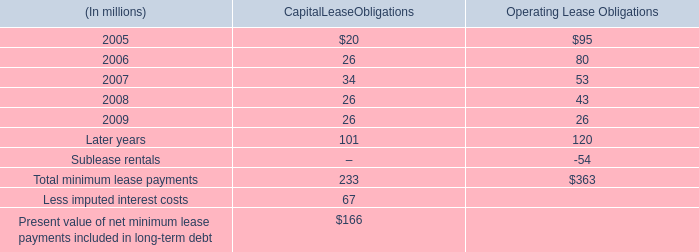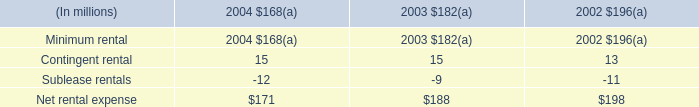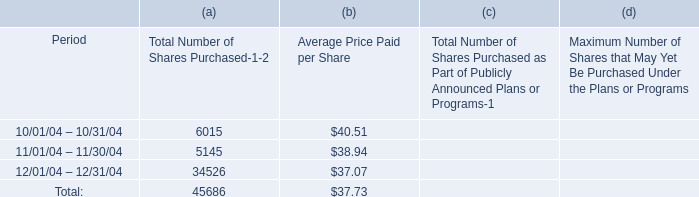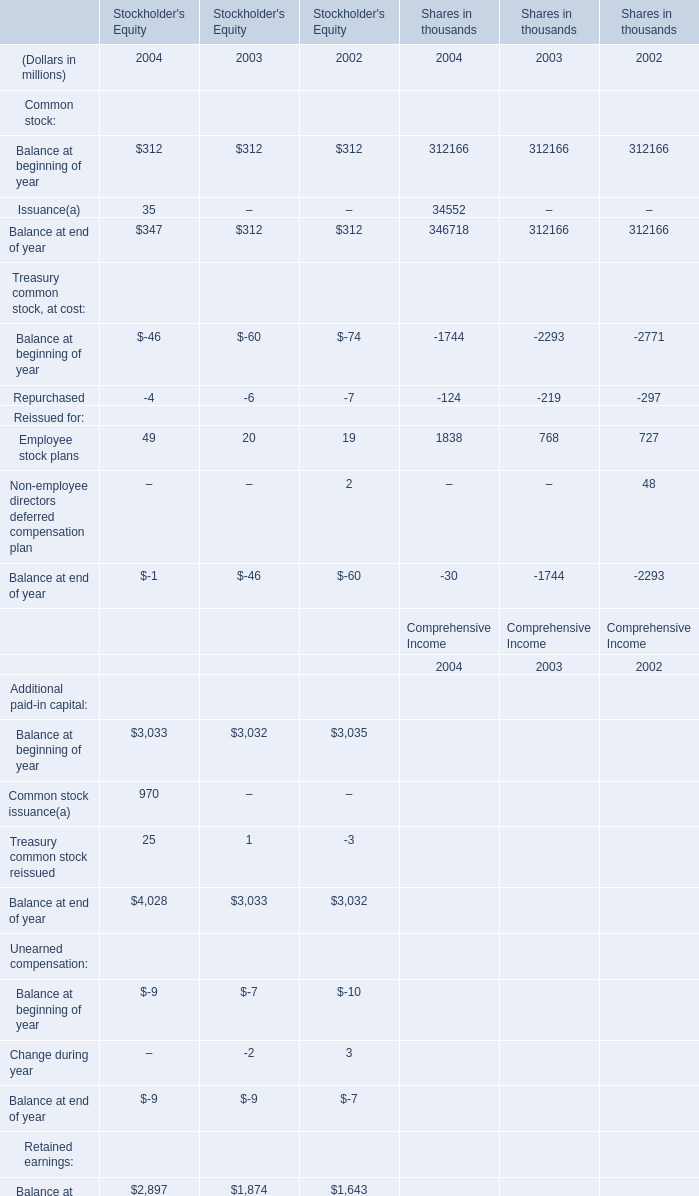Does Balance at end of year for Common stock in Stockholder's Equity keeps increasing each year between 2003 and 2002? 
Answer: No. 